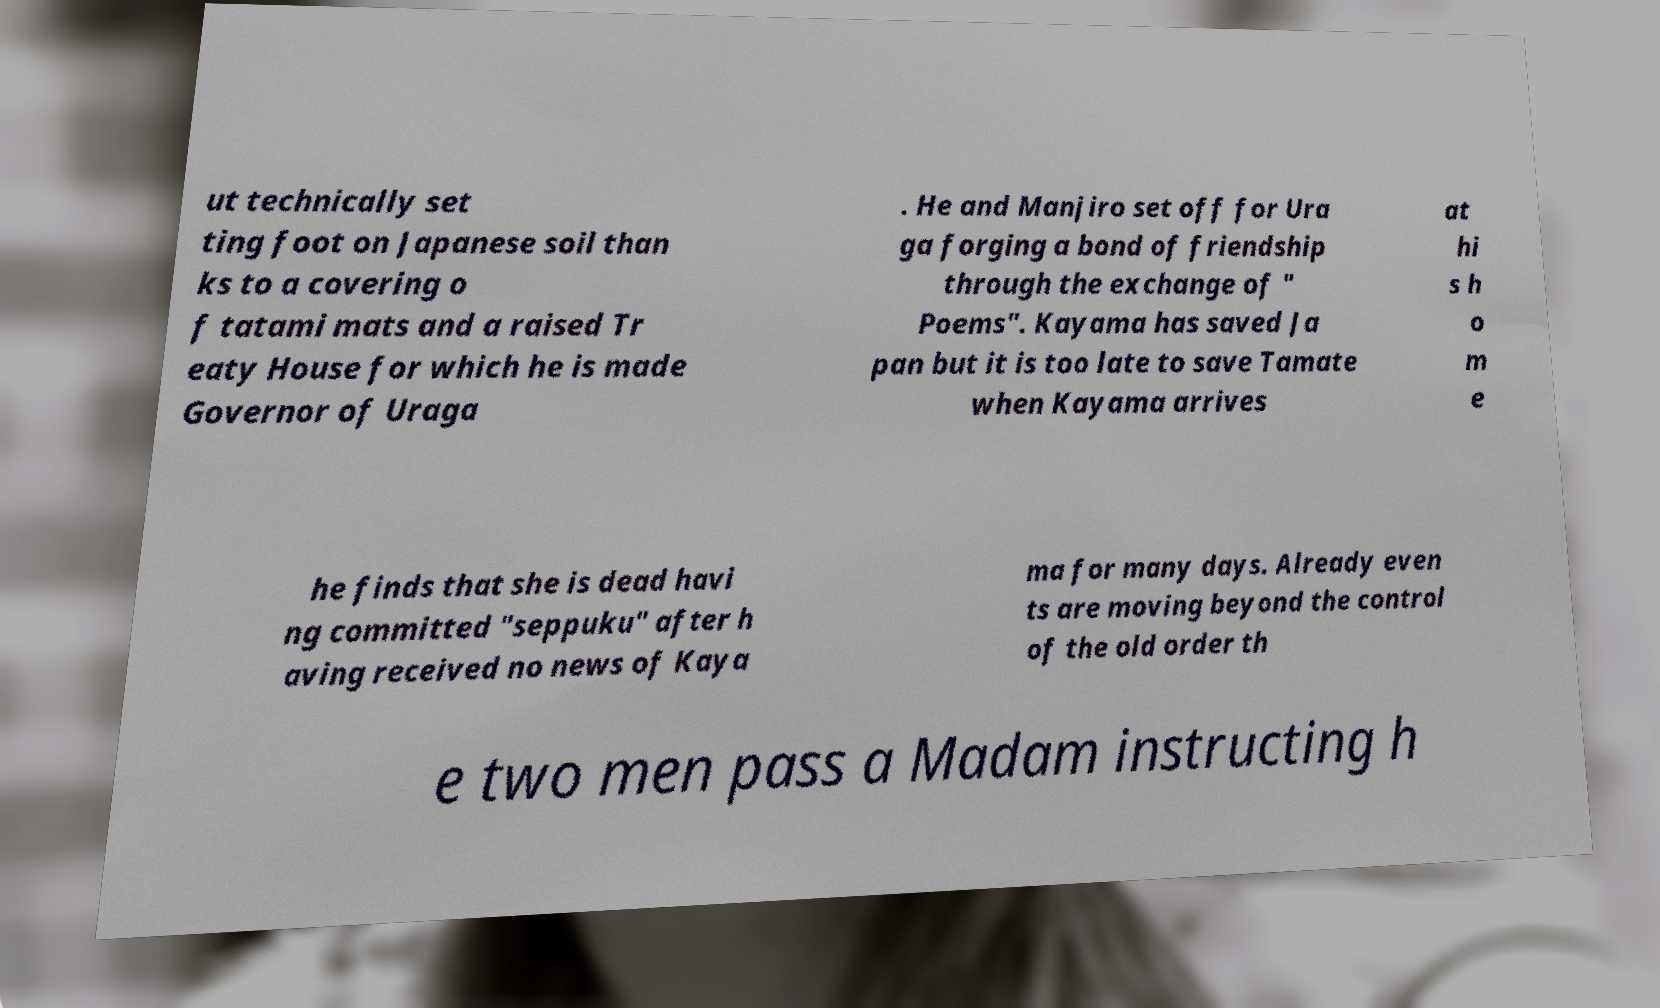Could you extract and type out the text from this image? ut technically set ting foot on Japanese soil than ks to a covering o f tatami mats and a raised Tr eaty House for which he is made Governor of Uraga . He and Manjiro set off for Ura ga forging a bond of friendship through the exchange of " Poems". Kayama has saved Ja pan but it is too late to save Tamate when Kayama arrives at hi s h o m e he finds that she is dead havi ng committed "seppuku" after h aving received no news of Kaya ma for many days. Already even ts are moving beyond the control of the old order th e two men pass a Madam instructing h 